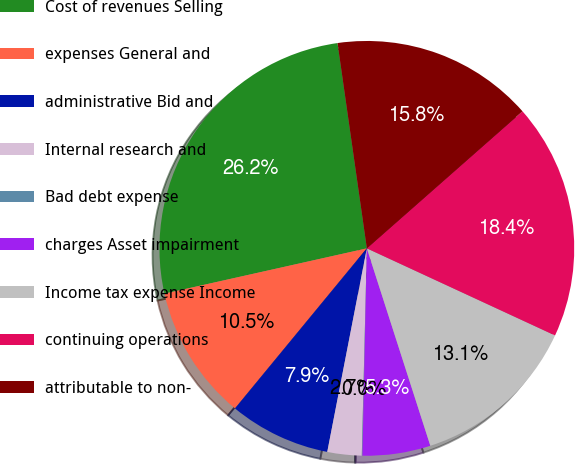Convert chart. <chart><loc_0><loc_0><loc_500><loc_500><pie_chart><fcel>Cost of revenues Selling<fcel>expenses General and<fcel>administrative Bid and<fcel>Internal research and<fcel>Bad debt expense<fcel>charges Asset impairment<fcel>Income tax expense Income<fcel>continuing operations<fcel>attributable to non-<nl><fcel>26.25%<fcel>10.53%<fcel>7.91%<fcel>2.67%<fcel>0.05%<fcel>5.29%<fcel>13.15%<fcel>18.39%<fcel>15.77%<nl></chart> 